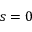<formula> <loc_0><loc_0><loc_500><loc_500>s = 0</formula> 